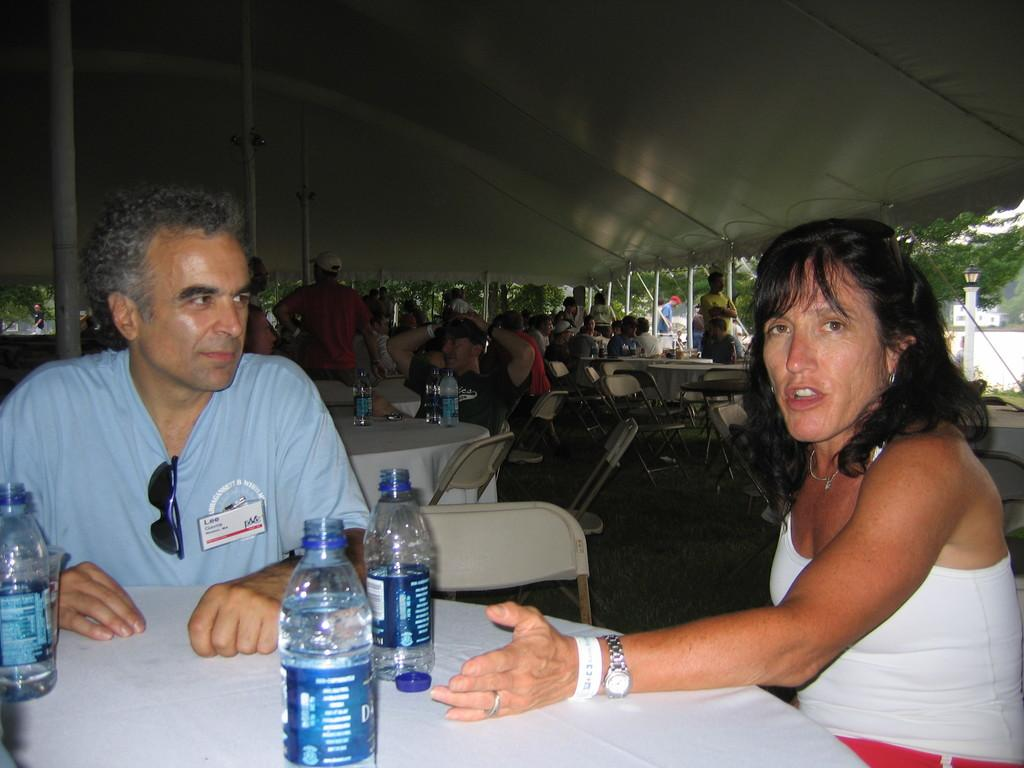What is the man doing in the image? The man is sitting on a chair on the right side of the image. What is the woman doing in the image? The woman is talking on the left side of the image. What objects are on the table in the image? There are water bottles on a table in the image. What type of poison is being used by the man in the image? There is no poison present in the image; the man is simply sitting on a chair. 